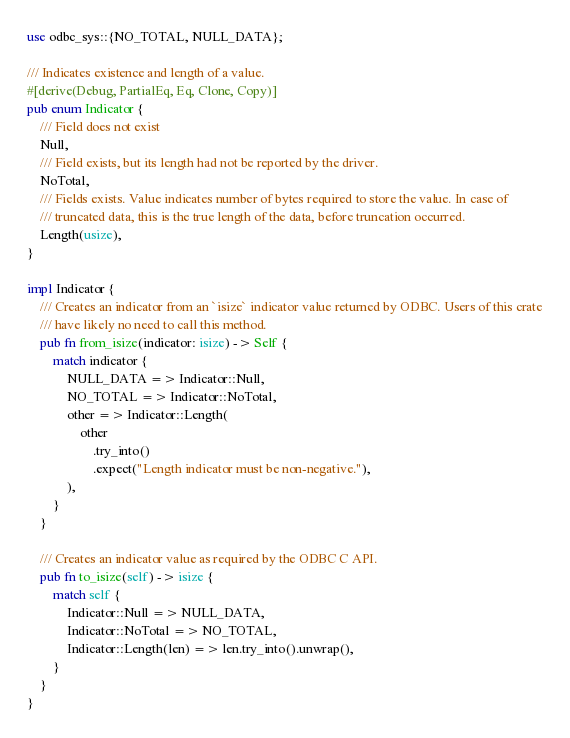<code> <loc_0><loc_0><loc_500><loc_500><_Rust_>use odbc_sys::{NO_TOTAL, NULL_DATA};

/// Indicates existence and length of a value.
#[derive(Debug, PartialEq, Eq, Clone, Copy)]
pub enum Indicator {
    /// Field does not exist
    Null,
    /// Field exists, but its length had not be reported by the driver.
    NoTotal,
    /// Fields exists. Value indicates number of bytes required to store the value. In case of
    /// truncated data, this is the true length of the data, before truncation occurred.
    Length(usize),
}

impl Indicator {
    /// Creates an indicator from an `isize` indicator value returned by ODBC. Users of this crate
    /// have likely no need to call this method.
    pub fn from_isize(indicator: isize) -> Self {
        match indicator {
            NULL_DATA => Indicator::Null,
            NO_TOTAL => Indicator::NoTotal,
            other => Indicator::Length(
                other
                    .try_into()
                    .expect("Length indicator must be non-negative."),
            ),
        }
    }

    /// Creates an indicator value as required by the ODBC C API.
    pub fn to_isize(self) -> isize {
        match self {
            Indicator::Null => NULL_DATA,
            Indicator::NoTotal => NO_TOTAL,
            Indicator::Length(len) => len.try_into().unwrap(),
        }
    }
}
</code> 